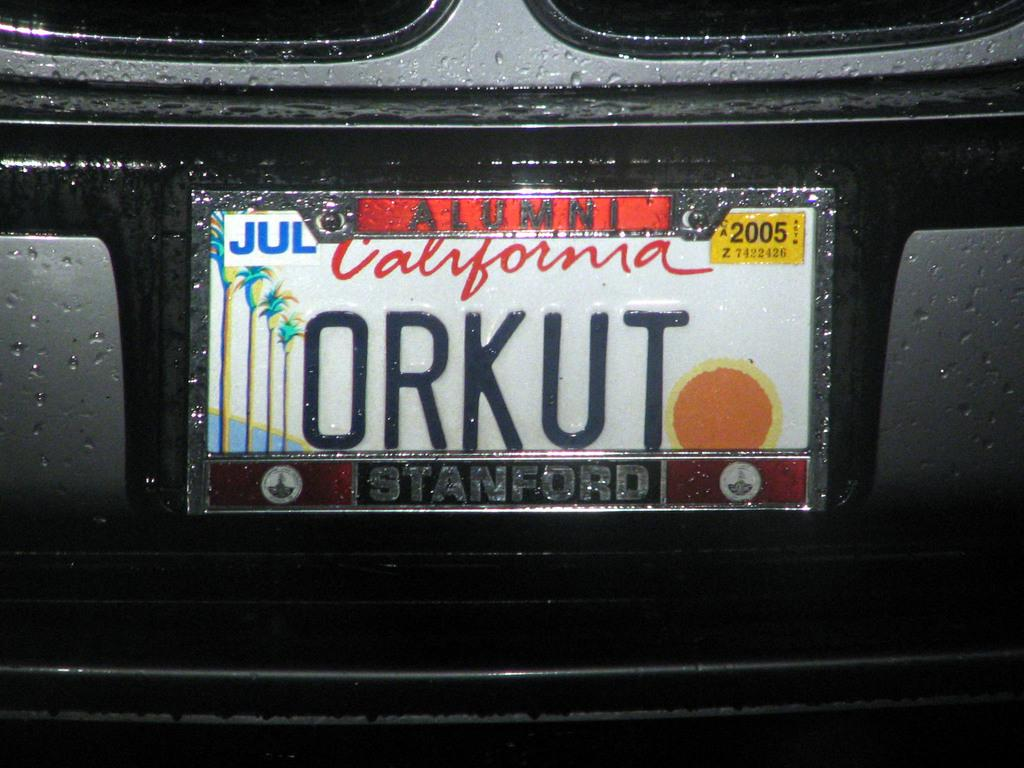<image>
Summarize the visual content of the image. White California license plate that says ORKUT on it. 